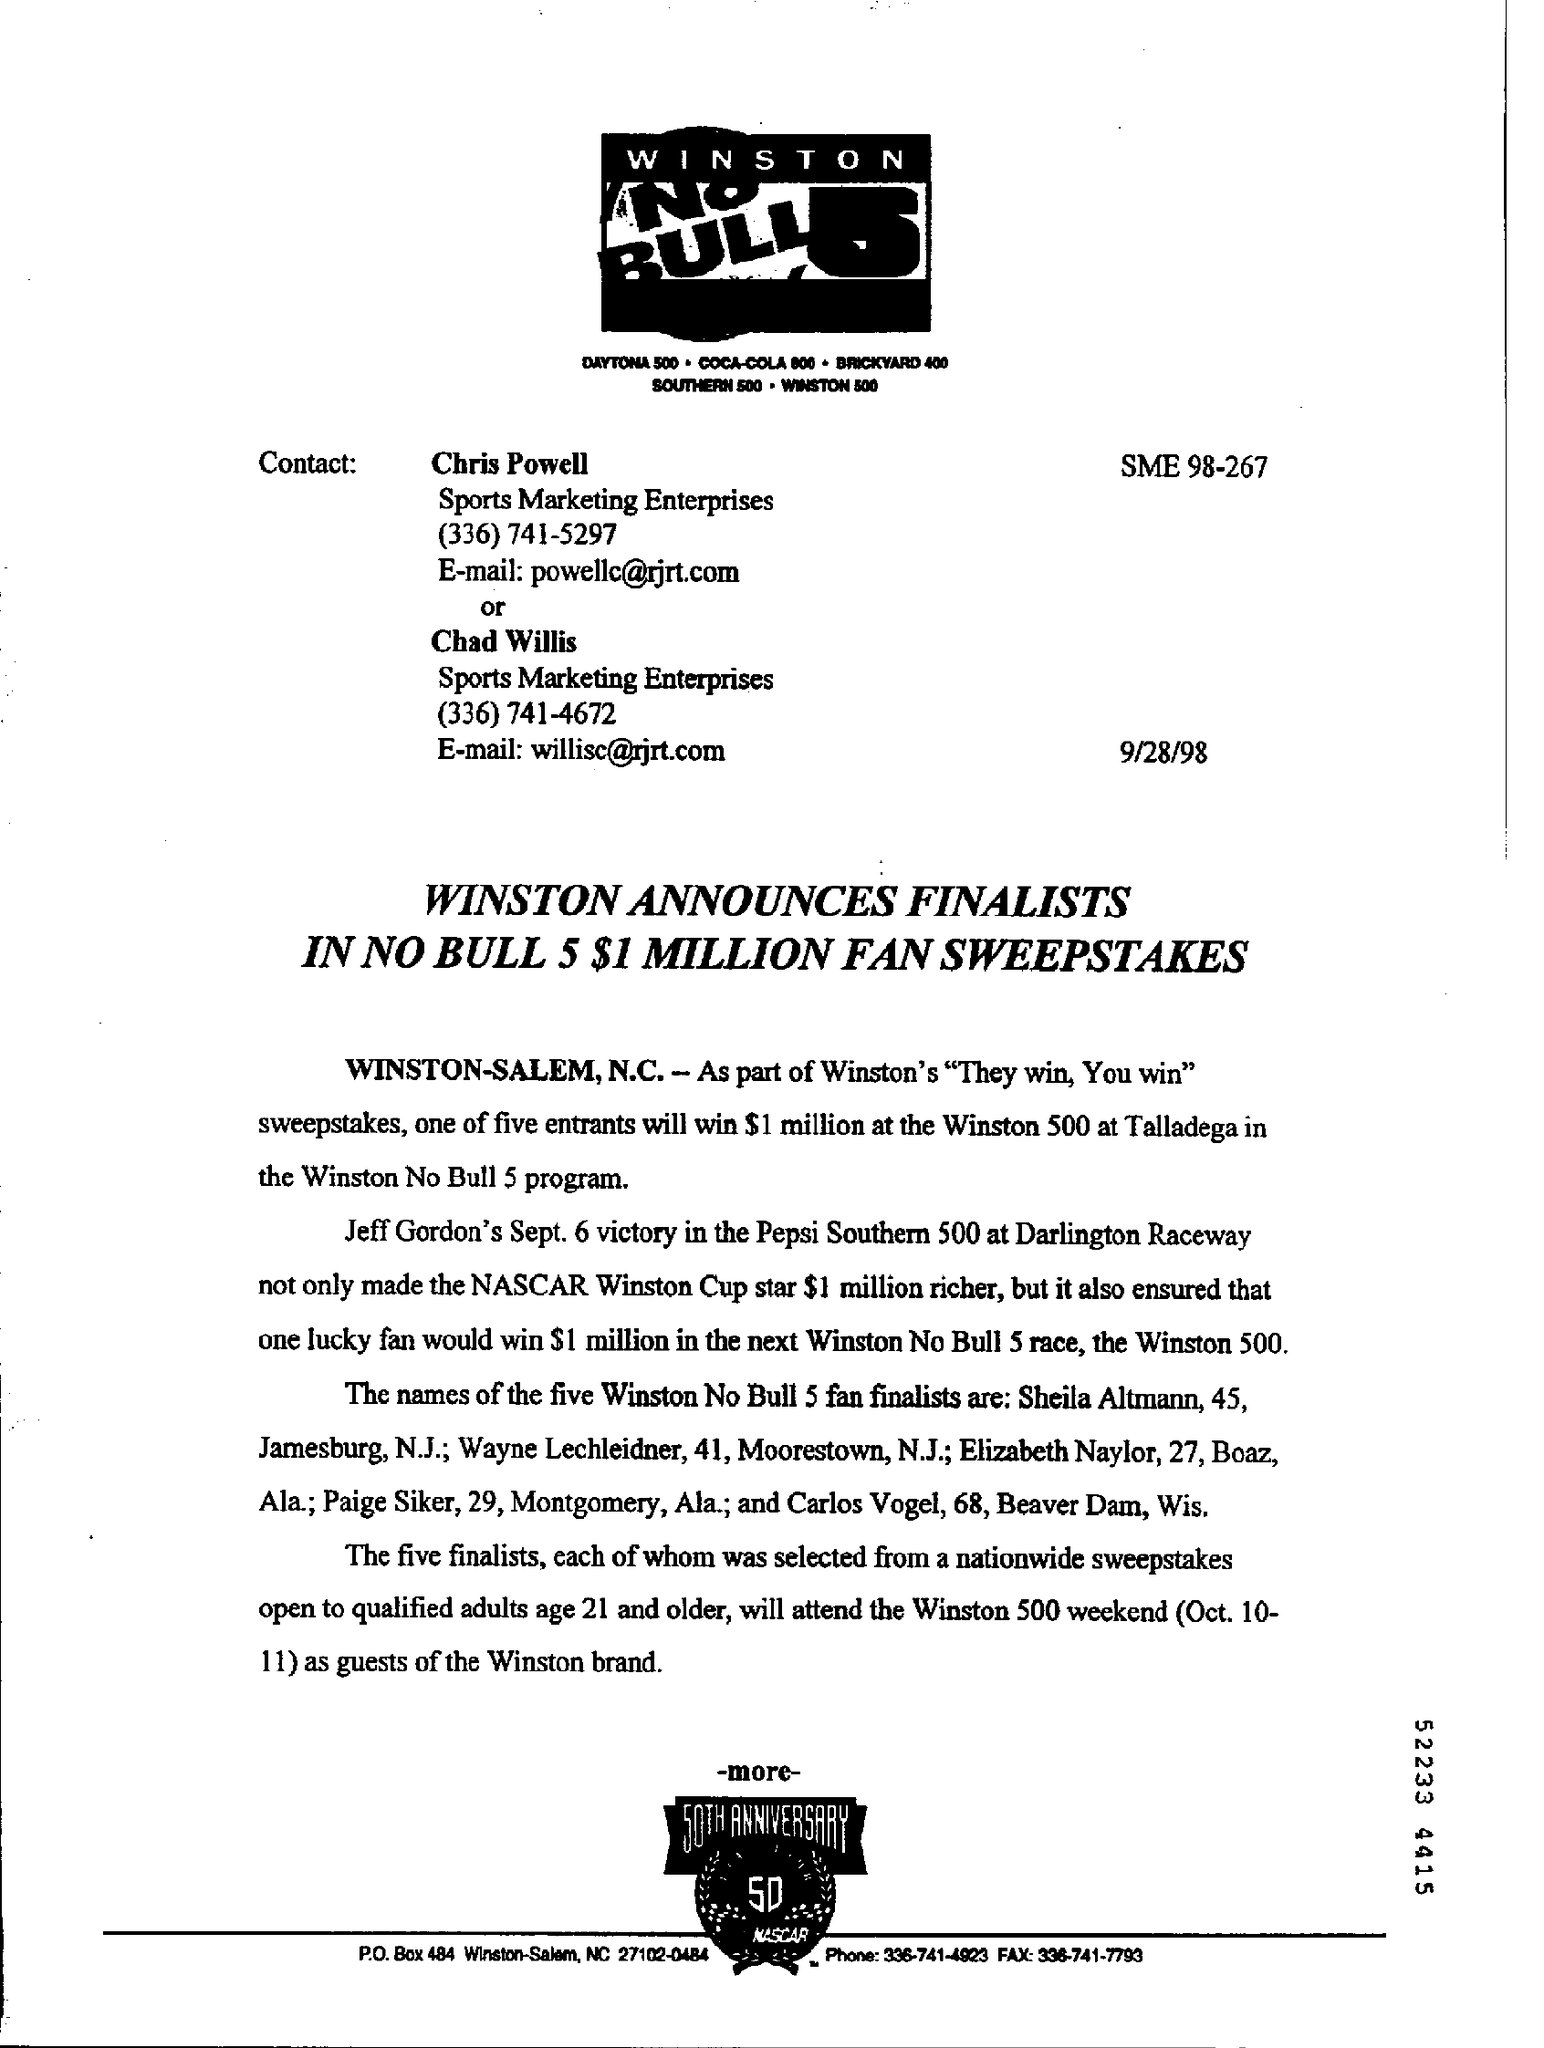Specify some key components in this picture. The document indicates a date of September 28, 1998. 